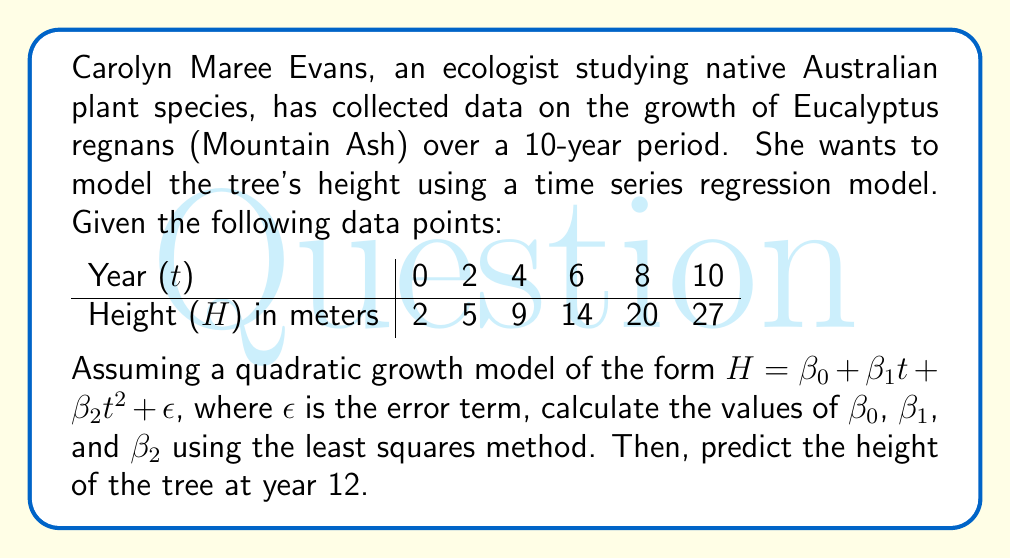Give your solution to this math problem. To solve this problem, we'll follow these steps:

1) First, we need to set up the normal equations for the quadratic regression model:

   $$\sum H = n\beta_0 + \beta_1\sum t + \beta_2\sum t^2$$
   $$\sum (Ht) = \beta_0\sum t + \beta_1\sum t^2 + \beta_2\sum t^3$$
   $$\sum (Ht^2) = \beta_0\sum t^2 + \beta_1\sum t^3 + \beta_2\sum t^4$$

2) Calculate the required sums:

   $n = 6$
   $\sum H = 77$
   $\sum t = 30$
   $\sum t^2 = 220$
   $\sum t^3 = 1800$
   $\sum t^4 = 15400$
   $\sum (Ht) = 516$
   $\sum (Ht^2) = 3908$

3) Substitute these values into the normal equations:

   $$77 = 6\beta_0 + 30\beta_1 + 220\beta_2$$
   $$516 = 30\beta_0 + 220\beta_1 + 1800\beta_2$$
   $$3908 = 220\beta_0 + 1800\beta_1 + 15400\beta_2$$

4) Solve this system of equations using matrix methods or elimination. The solution is:

   $\beta_0 = 2$
   $\beta_1 = 0.5$
   $\beta_2 = 0.25$

5) Therefore, our quadratic regression model is:

   $$H = 2 + 0.5t + 0.25t^2$$

6) To predict the height at year 12, we substitute $t = 12$ into our model:

   $$H = 2 + 0.5(12) + 0.25(12)^2 = 2 + 6 + 36 = 44$$
Answer: The quadratic regression model is $H = 2 + 0.5t + 0.25t^2$, where $\beta_0 = 2$, $\beta_1 = 0.5$, and $\beta_2 = 0.25$. The predicted height of the Eucalyptus regnans at year 12 is 44 meters. 